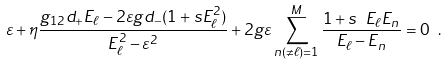<formula> <loc_0><loc_0><loc_500><loc_500>\varepsilon + \eta \frac { g _ { 1 2 } d _ { + } { E } _ { \ell } - 2 \varepsilon g d _ { - } ( 1 + s E _ { \ell } ^ { 2 } ) } { { E } _ { \ell } ^ { 2 } - \varepsilon ^ { 2 } } + 2 g \varepsilon \sum _ { n \left ( \neq \ell \right ) = 1 } ^ { M } \frac { 1 + s \ { E } _ { \ell } { E } _ { n } } { { E } _ { \ell } - { E } _ { n } } = 0 \ .</formula> 